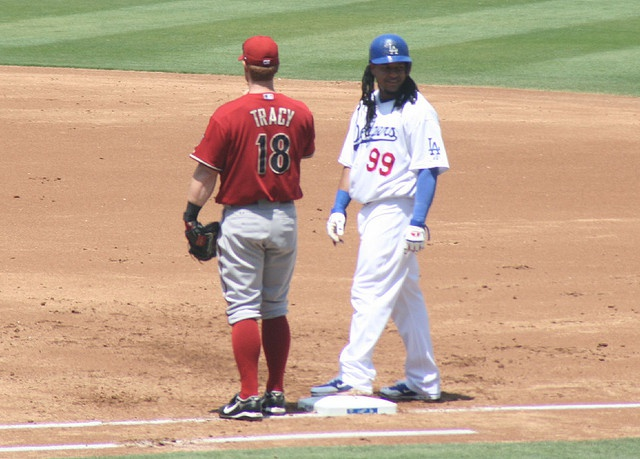Describe the objects in this image and their specific colors. I can see people in olive, maroon, gray, brown, and lightgray tones, people in olive, white, darkgray, and tan tones, and baseball glove in olive, black, gray, and maroon tones in this image. 